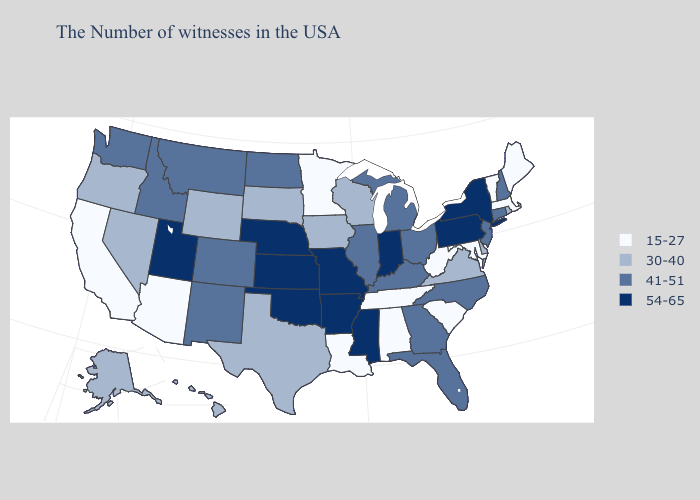What is the value of Maryland?
Write a very short answer. 15-27. Does the first symbol in the legend represent the smallest category?
Be succinct. Yes. Name the states that have a value in the range 41-51?
Short answer required. New Hampshire, Connecticut, New Jersey, North Carolina, Ohio, Florida, Georgia, Michigan, Kentucky, Illinois, North Dakota, Colorado, New Mexico, Montana, Idaho, Washington. Among the states that border Utah , does Wyoming have the highest value?
Give a very brief answer. No. What is the value of Tennessee?
Be succinct. 15-27. Does the map have missing data?
Keep it brief. No. What is the lowest value in the MidWest?
Keep it brief. 15-27. What is the value of Maine?
Concise answer only. 15-27. Among the states that border Rhode Island , does Connecticut have the lowest value?
Keep it brief. No. What is the lowest value in the MidWest?
Be succinct. 15-27. Name the states that have a value in the range 30-40?
Write a very short answer. Rhode Island, Delaware, Virginia, Wisconsin, Iowa, Texas, South Dakota, Wyoming, Nevada, Oregon, Alaska, Hawaii. What is the value of Pennsylvania?
Keep it brief. 54-65. What is the value of New Jersey?
Short answer required. 41-51. Does Nebraska have a higher value than Texas?
Quick response, please. Yes. What is the value of Idaho?
Concise answer only. 41-51. 